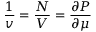Convert formula to latex. <formula><loc_0><loc_0><loc_500><loc_500>\frac { 1 } { v } = \frac { N } { V } = \frac { \partial P } { \partial \mu }</formula> 